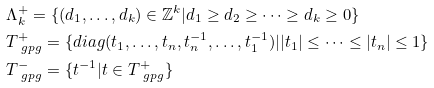<formula> <loc_0><loc_0><loc_500><loc_500>& \Lambda _ { k } ^ { + } = \{ ( d _ { 1 } , \dots , d _ { k } ) \in \mathbb { Z } ^ { k } | d _ { 1 } \geq d _ { 2 } \geq \dots \geq d _ { k } \geq 0 \} \\ & T _ { \ g p g } ^ { + } = \{ d i a g ( t _ { 1 } , \dots , t _ { n } , t _ { n } ^ { - 1 } , \dots , t _ { 1 } ^ { - 1 } ) | | t _ { 1 } | \leq \dots \leq | t _ { n } | \leq 1 \} \\ & T _ { \ g p g } ^ { - } = \{ t ^ { - 1 } | t \in T _ { \ g p g } ^ { + } \}</formula> 